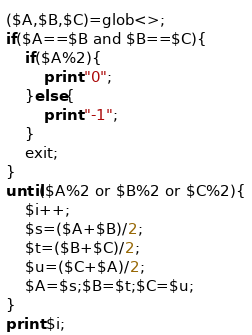<code> <loc_0><loc_0><loc_500><loc_500><_Perl_>($A,$B,$C)=glob<>;
if($A==$B and $B==$C){
    if($A%2){
        print "0";
    }else{
        print "-1";
    }
    exit;
}
until($A%2 or $B%2 or $C%2){
    $i++;
    $s=($A+$B)/2;
    $t=($B+$C)/2;
    $u=($C+$A)/2;
    $A=$s;$B=$t;$C=$u;
}
print $i;</code> 